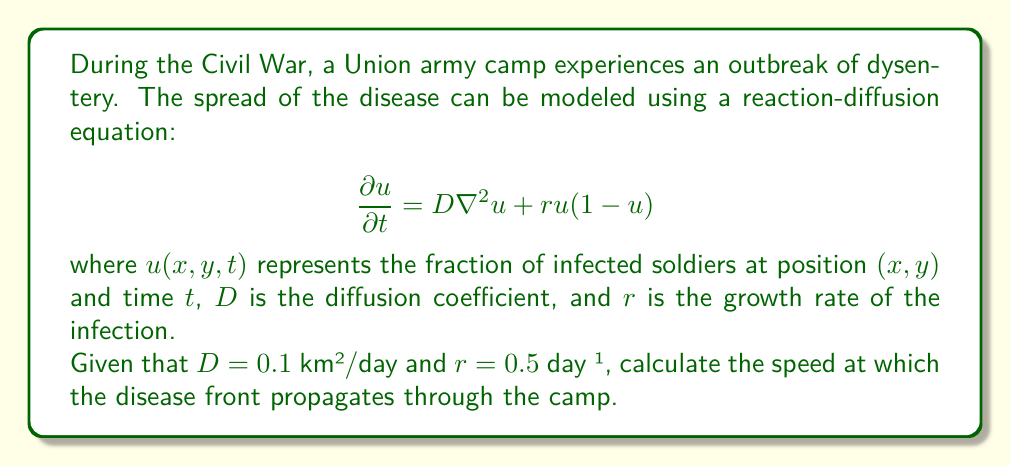Solve this math problem. To solve this problem, we'll use the Fisher-Kolmogorov equation, which is a special case of the reaction-diffusion equation given in the question.

1) The speed of propagation for the Fisher-Kolmogorov equation is given by:

   $$c = 2\sqrt{Dr}$$

   where $c$ is the speed of the disease front, $D$ is the diffusion coefficient, and $r$ is the growth rate.

2) We are given:
   $D = 0.1$ km²/day
   $r = 0.5$ day⁻¹

3) Substituting these values into the equation:

   $$c = 2\sqrt{(0.1 \text{ km²/day})(0.5 \text{ day}⁻¹)}$$

4) Simplify under the square root:

   $$c = 2\sqrt{0.05 \text{ km²/day²}}$$

5) Calculate the square root:

   $$c = 2(0.2236 \text{ km/day})$$

6) Multiply:

   $$c = 0.4472 \text{ km/day}$$

This result represents the speed at which the disease front moves through the Union army camp.
Answer: The disease front propagates through the camp at a speed of approximately 0.4472 km/day. 